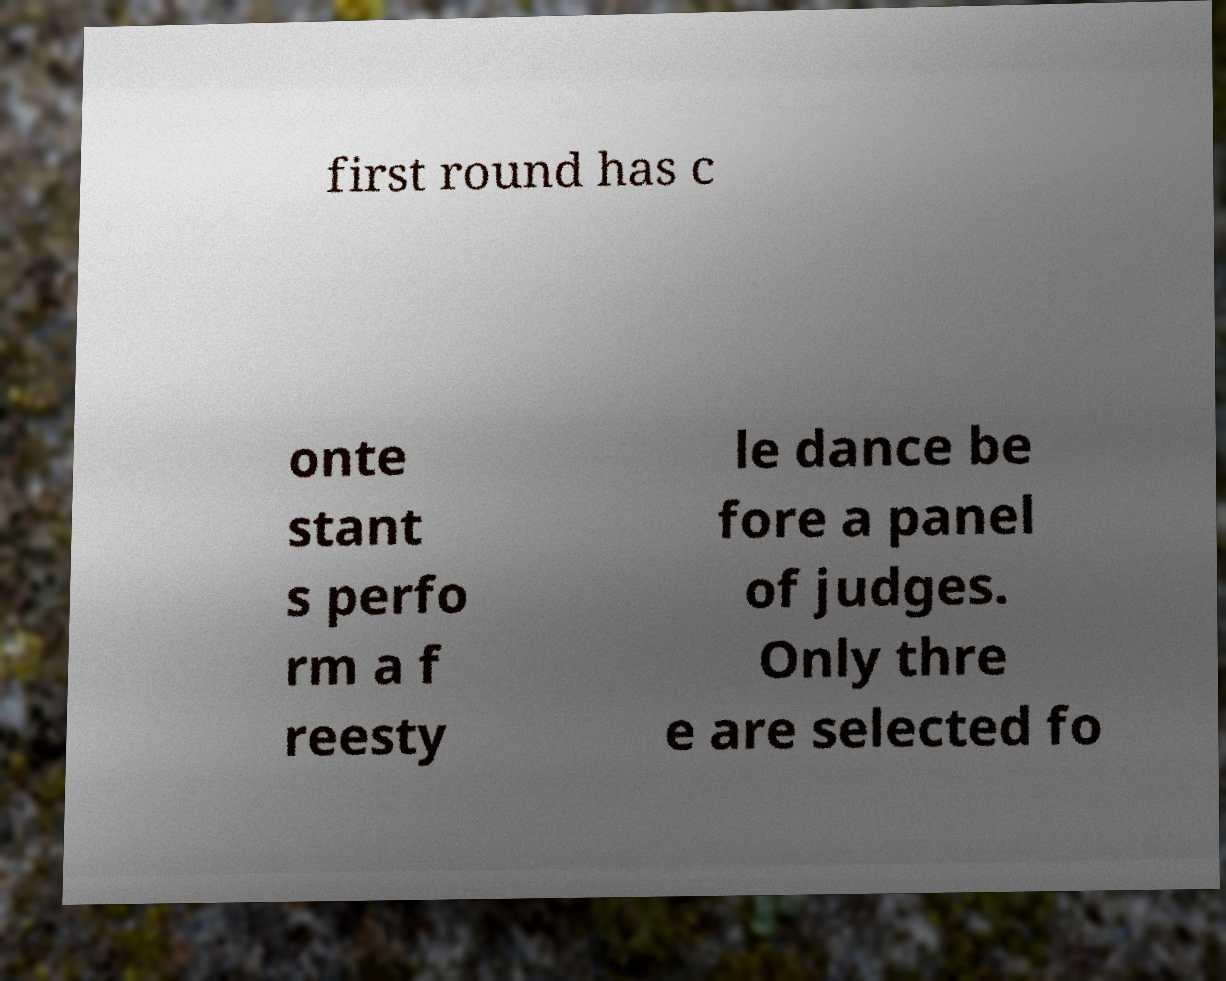What messages or text are displayed in this image? I need them in a readable, typed format. first round has c onte stant s perfo rm a f reesty le dance be fore a panel of judges. Only thre e are selected fo 